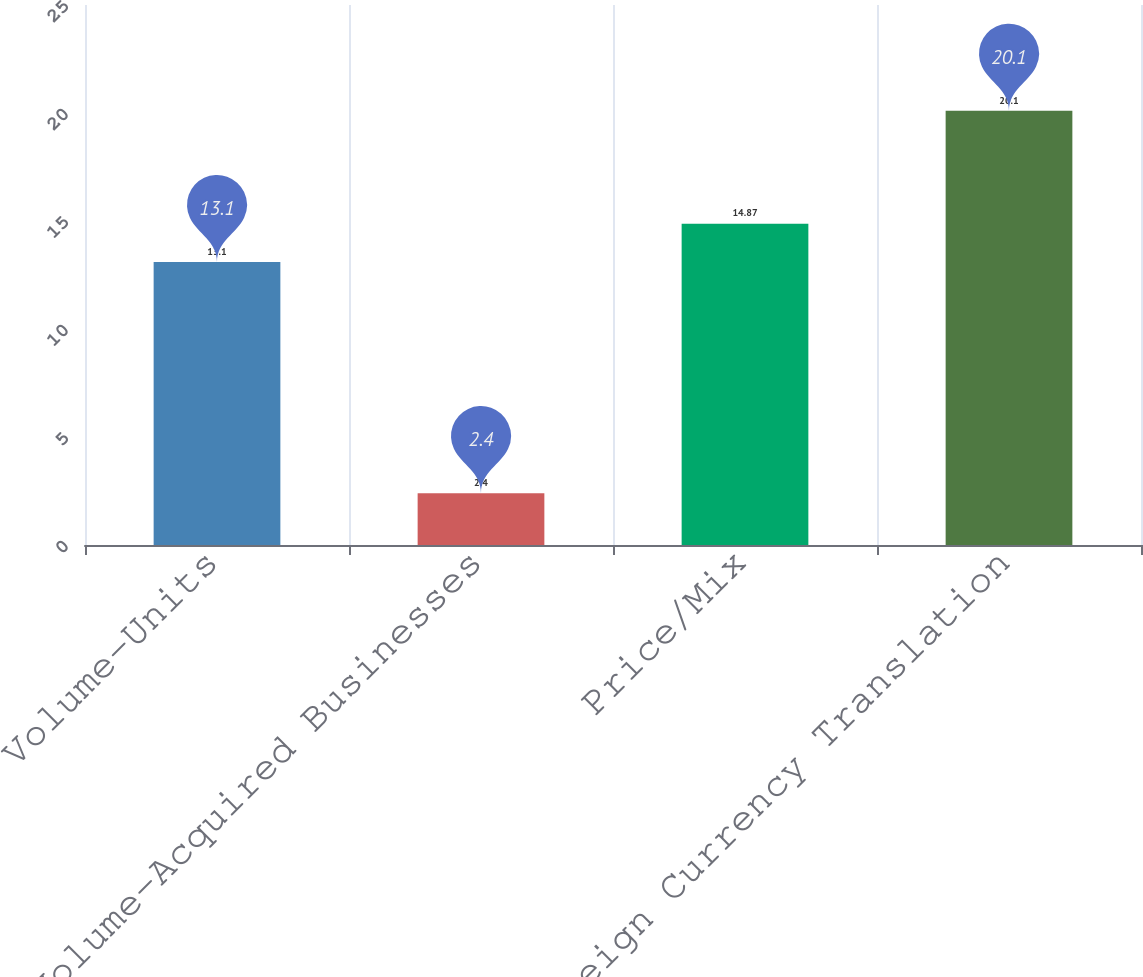Convert chart. <chart><loc_0><loc_0><loc_500><loc_500><bar_chart><fcel>Volume-Units<fcel>Volume-Acquired Businesses<fcel>Price/Mix<fcel>Foreign Currency Translation<nl><fcel>13.1<fcel>2.4<fcel>14.87<fcel>20.1<nl></chart> 